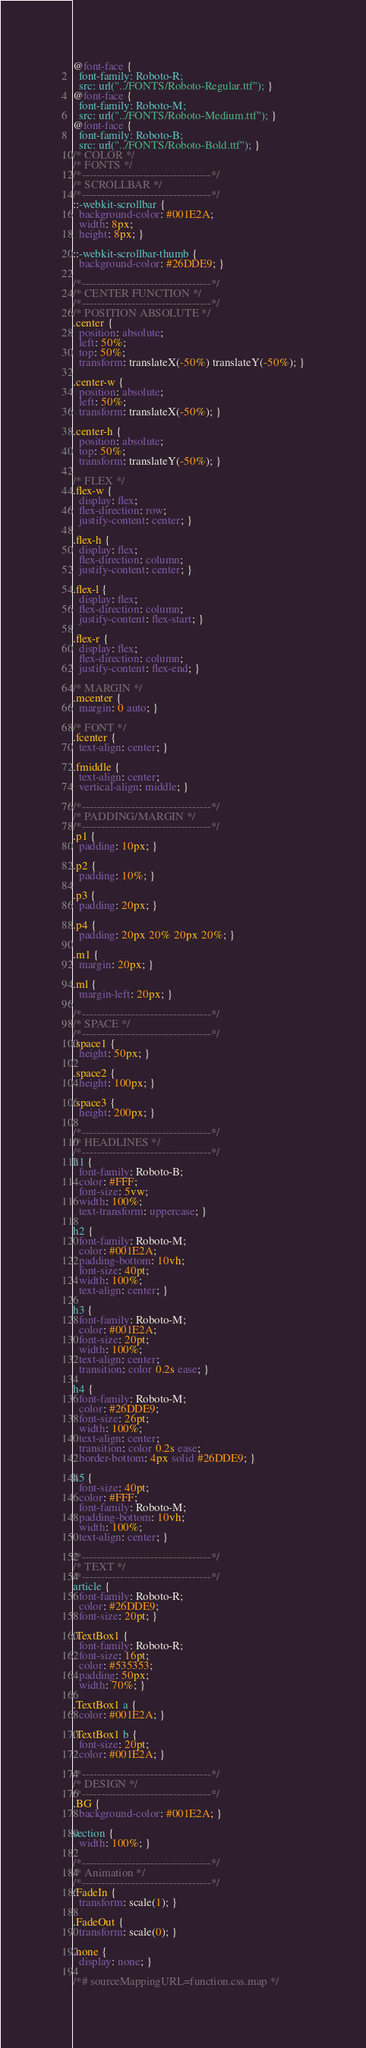Convert code to text. <code><loc_0><loc_0><loc_500><loc_500><_CSS_>@font-face {
  font-family: Roboto-R;
  src: url("../FONTS/Roboto-Regular.ttf"); }
@font-face {
  font-family: Roboto-M;
  src: url("../FONTS/Roboto-Medium.ttf"); }
@font-face {
  font-family: Roboto-B;
  src: url("../FONTS/Roboto-Bold.ttf"); }
/* COLOR */
/* FONTS */
/*----------------------------------*/
/* SCROLLBAR */
/*----------------------------------*/
::-webkit-scrollbar {
  background-color: #001E2A;
  width: 8px;
  height: 8px; }

::-webkit-scrollbar-thumb {
  background-color: #26DDE9; }

/*----------------------------------*/
/* CENTER FUNCTION */
/*----------------------------------*/
/* POSITION ABSOLUTE */
.center {
  position: absolute;
  left: 50%;
  top: 50%;
  transform: translateX(-50%) translateY(-50%); }

.center-w {
  position: absolute;
  left: 50%;
  transform: translateX(-50%); }

.center-h {
  position: absolute;
  top: 50%;
  transform: translateY(-50%); }

/* FLEX */
.flex-w {
  display: flex;
  flex-direction: row;
  justify-content: center; }

.flex-h {
  display: flex;
  flex-direction: column;
  justify-content: center; }

.flex-l {
  display: flex;
  flex-direction: column;
  justify-content: flex-start; }

.flex-r {
  display: flex;
  flex-direction: column;
  justify-content: flex-end; }

/* MARGIN */
.mcenter {
  margin: 0 auto; }

/* FONT */
.fcenter {
  text-align: center; }

.fmiddle {
  text-align: center;
  vertical-align: middle; }

/*----------------------------------*/
/* PADDING/MARGIN */
/*----------------------------------*/
.p1 {
  padding: 10px; }

.p2 {
  padding: 10%; }

.p3 {
  padding: 20px; }

.p4 {
  padding: 20px 20% 20px 20%; }

.m1 {
  margin: 20px; }

.ml {
  margin-left: 20px; }

/*----------------------------------*/
/* SPACE */
/*----------------------------------*/
.space1 {
  height: 50px; }

.space2 {
  height: 100px; }

.space3 {
  height: 200px; }

/*----------------------------------*/
/* HEADLINES */
/*----------------------------------*/
h1 {
  font-family: Roboto-B;
  color: #FFF;
  font-size: 5vw;
  width: 100%;
  text-transform: uppercase; }

h2 {
  font-family: Roboto-M;
  color: #001E2A;
  padding-bottom: 10vh;
  font-size: 40pt;
  width: 100%;
  text-align: center; }

h3 {
  font-family: Roboto-M;
  color: #001E2A;
  font-size: 20pt;
  width: 100%;
  text-align: center;
  transition: color 0.2s ease; }

h4 {
  font-family: Roboto-M;
  color: #26DDE9;
  font-size: 26pt;
  width: 100%;
  text-align: center;
  transition: color 0.2s ease;
  border-bottom: 4px solid #26DDE9; }

h5 {
  font-size: 40pt;
  color: #FFF;
  font-family: Roboto-M;
  padding-bottom: 10vh;
  width: 100%;
  text-align: center; }

/*----------------------------------*/
/* TEXT */
/*----------------------------------*/
article {
  font-family: Roboto-R;
  color: #26DDE9;
  font-size: 20pt; }

.TextBox1 {
  font-family: Roboto-R;
  font-size: 16pt;
  color: #535353;
  padding: 50px;
  width: 70%; }

.TextBox1 a {
  color: #001E2A; }

.TextBox1 b {
  font-size: 20pt;
  color: #001E2A; }

/*----------------------------------*/
/* DESIGN */
/*----------------------------------*/
.BG {
  background-color: #001E2A; }

section {
  width: 100%; }

/*----------------------------------*/
/* Animation */
/*----------------------------------*/
.FadeIn {
  transform: scale(1); }

.FadeOut {
  transform: scale(0); }

.none {
  display: none; }

/*# sourceMappingURL=function.css.map */
</code> 